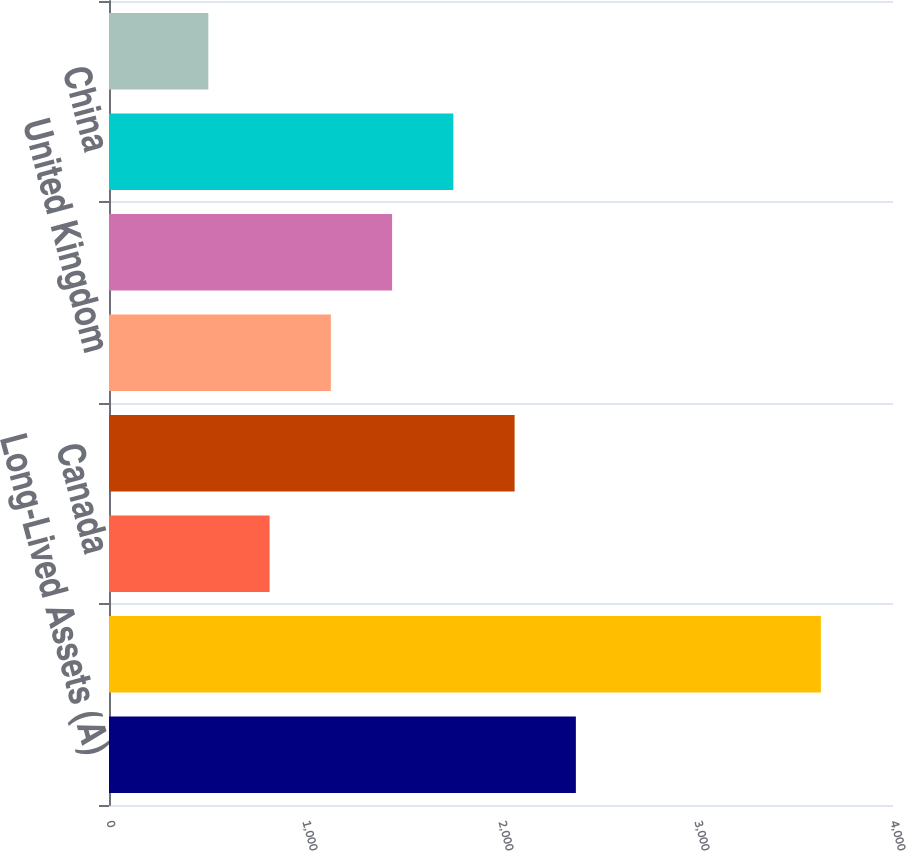<chart> <loc_0><loc_0><loc_500><loc_500><bar_chart><fcel>Long-Lived Assets (A)<fcel>United States<fcel>Canada<fcel>Europe excluding United<fcel>United Kingdom<fcel>Asia excluding China<fcel>China<fcel>Latin America<nl><fcel>2381.98<fcel>3632.1<fcel>819.33<fcel>2069.45<fcel>1131.86<fcel>1444.39<fcel>1756.92<fcel>506.8<nl></chart> 